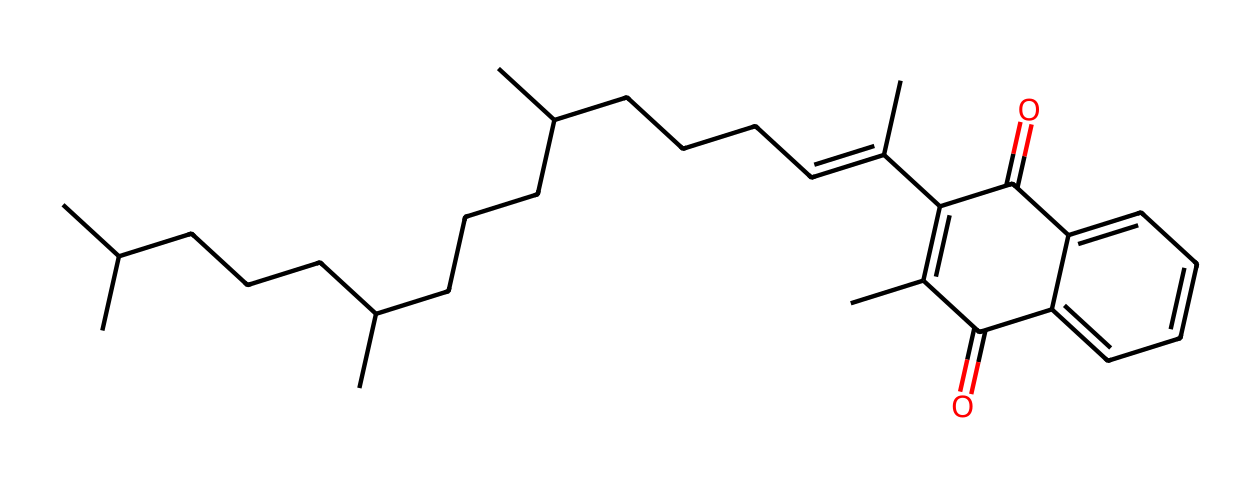What is the main functional group in vitamin K1? The structure contains a ketone and ingested molecular configurations related to carbonyl groups (C=O), indicating the presence of ketones. Thus, the main functional group is ketone.
Answer: ketone How many rings are present in the molecular structure? By analyzing the cyclic part of the structure, we can observe that there is one ring structure indicated by the cyclic notation in the SMILES representation.
Answer: one What is the molecular formula of vitamin K1 as inferred from the structure? The structure, when counted for each atom type (Carbon, Hydrogen, and Oxygen), shows that there are 30 carbon atoms, 40 hydrogen atoms, and 2 oxygen atoms, leading to a molecular formula of C30H40O2.
Answer: C30H40O2 What type of chemical is vitamin K1 classified as? Vitamin K1 is classified based on its functional groups and overall structure as a vitamin, particularly a fat-soluble vitamin due to the presence of long carbon chains in its structure.
Answer: vitamin What is the total number of double bonds in the structure? By inspecting the carbon chain and the ring structure, we can identify there are a total of three double bonds present, which contributes to the vitamin's chemical properties.
Answer: three Which part of the structure contributes to its role in blood clotting? The presence of the various carbonyl groups and the linked alkene indicates the vitamin's specific reactive sites, contributing to its role in activating clotting factors, thus emphasizing its role in metabolism.
Answer: carbonyl groups 